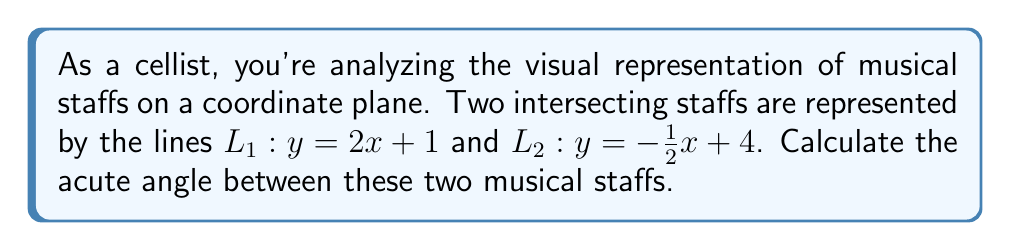Could you help me with this problem? To find the angle between two intersecting lines, we can use the formula:

$$\tan \theta = \left|\frac{m_1 - m_2}{1 + m_1m_2}\right|$$

Where $m_1$ and $m_2$ are the slopes of the two lines.

Step 1: Identify the slopes
$L_1: y = 2x + 1$, so $m_1 = 2$
$L_2: y = -\frac{1}{2}x + 4$, so $m_2 = -\frac{1}{2}$

Step 2: Substitute into the formula
$$\tan \theta = \left|\frac{2 - (-\frac{1}{2})}{1 + 2(-\frac{1}{2})}\right|$$

Step 3: Simplify
$$\tan \theta = \left|\frac{2 + \frac{1}{2}}{1 - 1}\right| = \left|\frac{\frac{5}{2}}{0}\right| = \frac{5}{2}$$

Step 4: Calculate the angle using inverse tangent
$$\theta = \arctan\left(\frac{5}{2}\right)$$

Step 5: Convert to degrees
$$\theta \approx 68.20^\circ$$
Answer: $68.20^\circ$ 